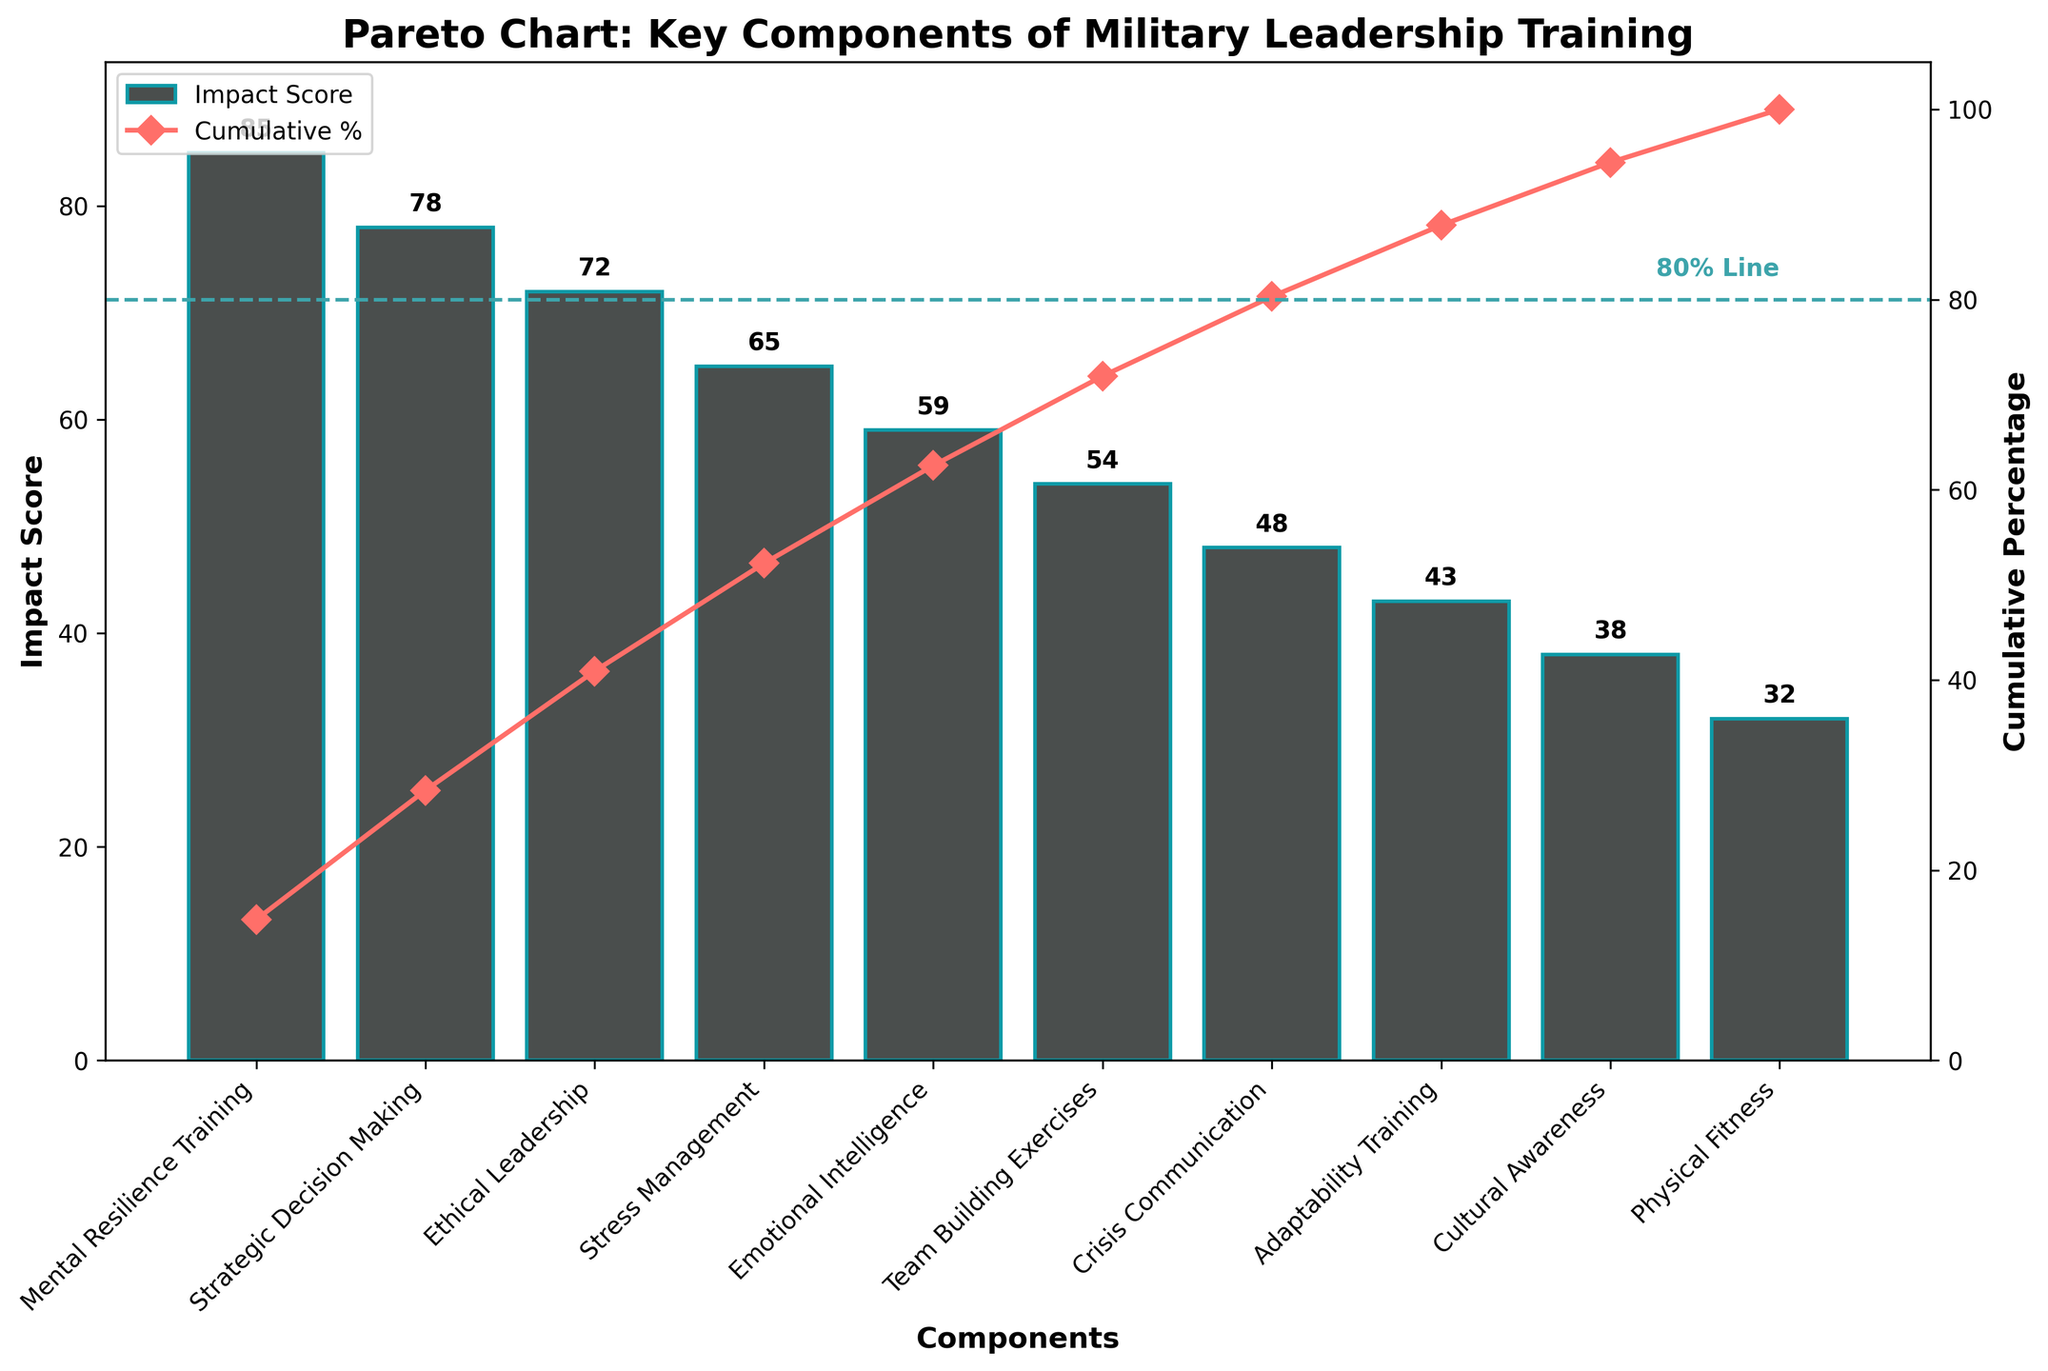What's the most impactful component according to the chart? The component with the highest bar in the Pareto chart represents the most impactful component. This is determined by checking the first bar, which has the highest impact score.
Answer: Mental Resilience Training What percentage of the total impact does the top three components contribute? To find the total impact of the top three components, sum their individual impact scores: 85 (Mental Resilience Training) + 78 (Strategic Decision Making) + 72 (Ethical Leadership) = 235. The cumulative percentage for these components can be found in the cumulative percentage line plot. As given in the plot, the cumulative percentage of the first three components is slightly above 80%.
Answer: About 80% Which component lies exactly at the 80% cumulative impact mark? The component lying at the 80% cumulative impact mark is found by looking at where the cumulative percentage line crosses the 80% mark on the y-axis. The 80% line intersects right after Ethical Leadership.
Answer: Ethical Leadership How many components are needed to achieve at least 95% of the cumulative impact? To find this, check the cumulative percentage line until it hits 95%. The plot shows this takes the first seven components.
Answer: 7 Which components are considered the least impactful? The least impactful components are identified by the shortest bars as identified at the right end of the chart, which in this case are Adaptability Training, Cultural Awareness, and Physical Fitness.
Answer: Adaptability Training, Cultural Awareness, and Physical Fitness 